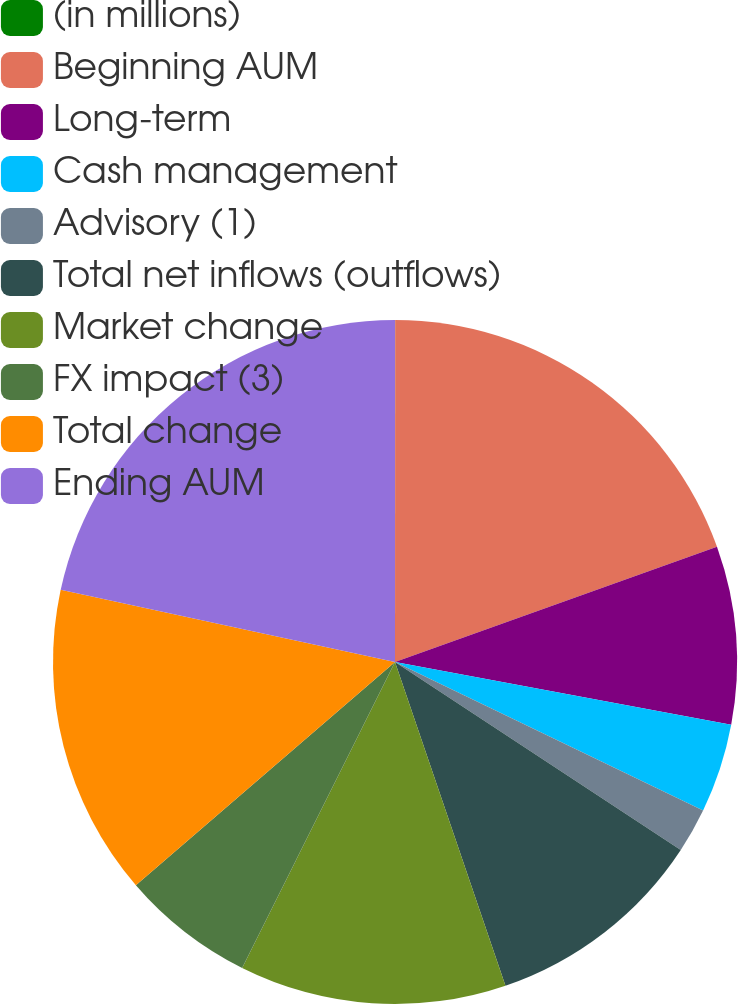<chart> <loc_0><loc_0><loc_500><loc_500><pie_chart><fcel>(in millions)<fcel>Beginning AUM<fcel>Long-term<fcel>Cash management<fcel>Advisory (1)<fcel>Total net inflows (outflows)<fcel>Market change<fcel>FX impact (3)<fcel>Total change<fcel>Ending AUM<nl><fcel>0.01%<fcel>19.52%<fcel>8.41%<fcel>4.21%<fcel>2.11%<fcel>10.51%<fcel>12.61%<fcel>6.31%<fcel>14.7%<fcel>21.62%<nl></chart> 